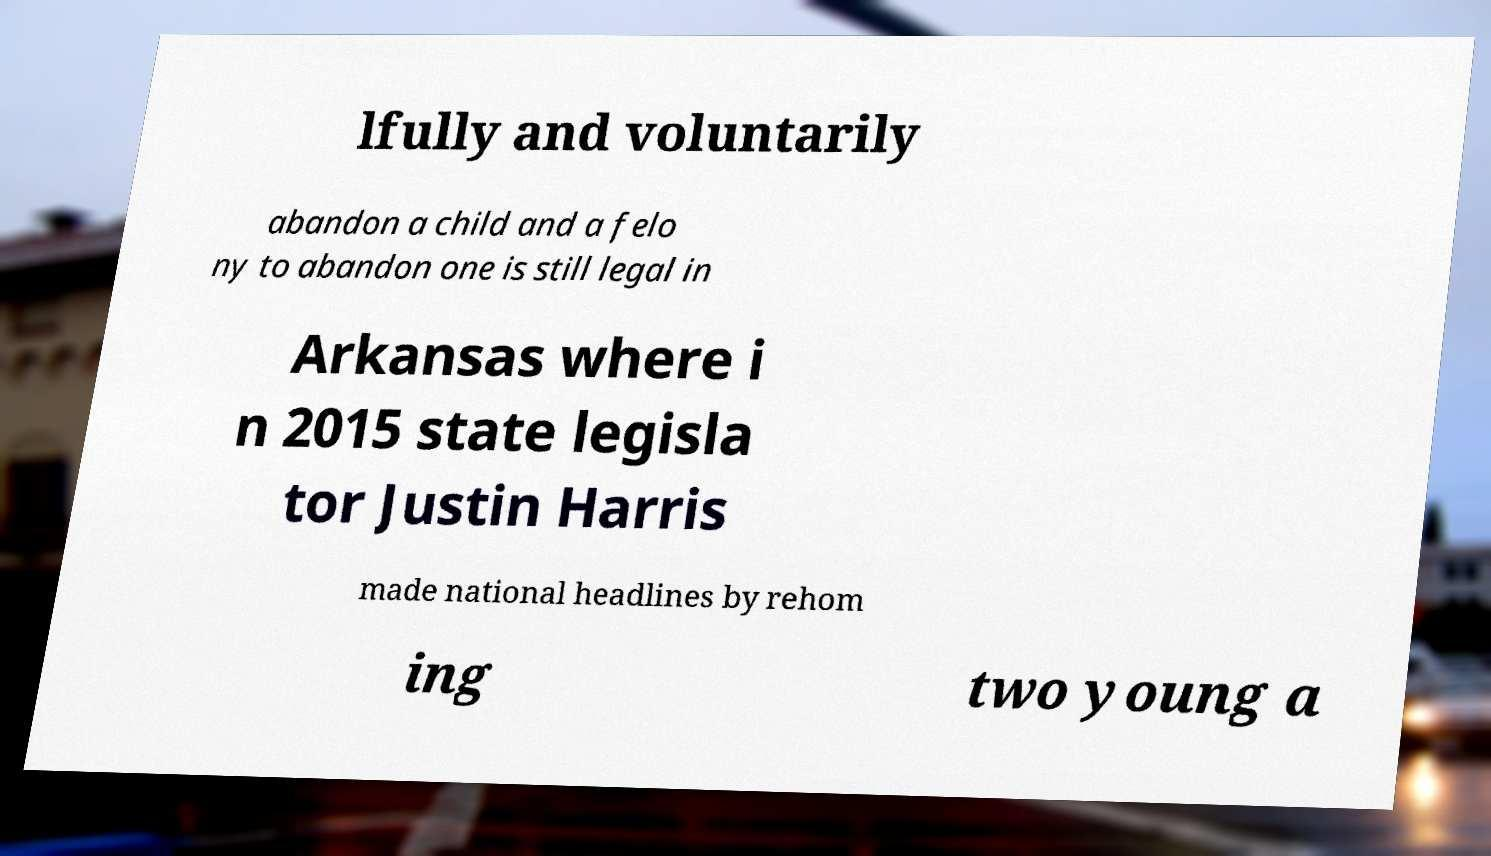For documentation purposes, I need the text within this image transcribed. Could you provide that? lfully and voluntarily abandon a child and a felo ny to abandon one is still legal in Arkansas where i n 2015 state legisla tor Justin Harris made national headlines by rehom ing two young a 